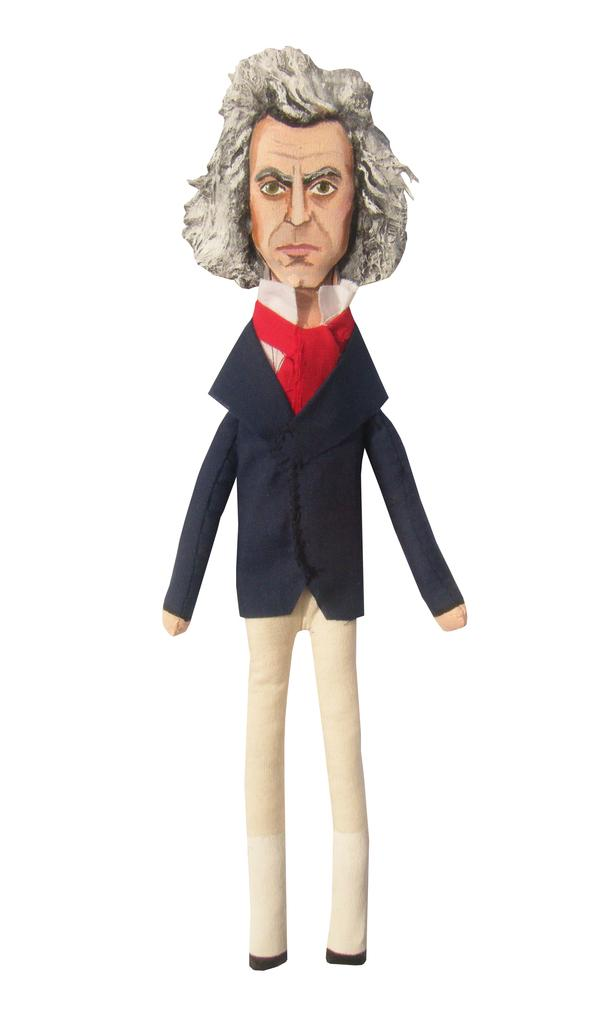What is the main subject of the image? There is a toy in the image. What does the toy represent? The toy represents a person. What color is the coat the person is wearing? The person is wearing a blue coat. What color are the pants the person is wearing? The person is wearing cream pants. What is the color and style of the person's hair? The person has short white hair. What type of animals can be seen at the zoo in the image? There is no zoo or animals present in the image; it features a toy representing a person. What structural elements can be observed in the image? The image does not depict any structural elements; it only shows a toy representing a person. 